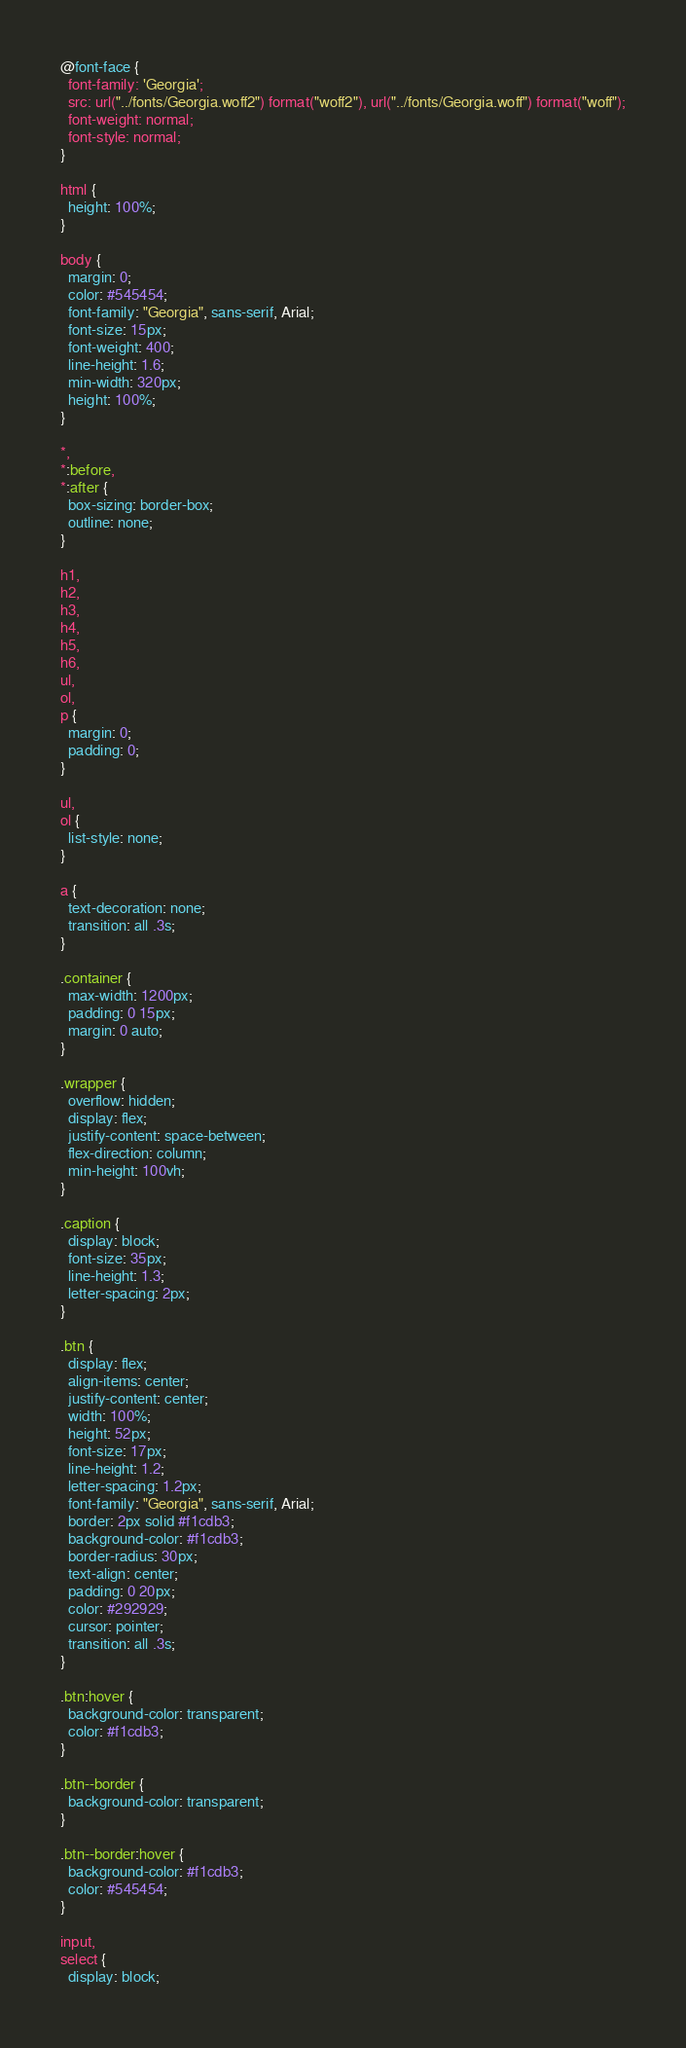<code> <loc_0><loc_0><loc_500><loc_500><_CSS_>@font-face {
  font-family: 'Georgia';
  src: url("../fonts/Georgia.woff2") format("woff2"), url("../fonts/Georgia.woff") format("woff");
  font-weight: normal;
  font-style: normal;
}

html {
  height: 100%;
}

body {
  margin: 0;
  color: #545454;
  font-family: "Georgia", sans-serif, Arial;
  font-size: 15px;
  font-weight: 400;
  line-height: 1.6;
  min-width: 320px;
  height: 100%;
}

*,
*:before,
*:after {
  box-sizing: border-box;
  outline: none;
}

h1,
h2,
h3,
h4,
h5,
h6,
ul,
ol,
p {
  margin: 0;
  padding: 0;
}

ul,
ol {
  list-style: none;
}

a {
  text-decoration: none;
  transition: all .3s;
}

.container {
  max-width: 1200px;
  padding: 0 15px;
  margin: 0 auto;
}

.wrapper {
  overflow: hidden;
  display: flex;
  justify-content: space-between;
  flex-direction: column;
  min-height: 100vh;
}

.caption {
  display: block;
  font-size: 35px;
  line-height: 1.3;
  letter-spacing: 2px;
}

.btn {
  display: flex;
  align-items: center;
  justify-content: center;
  width: 100%;
  height: 52px;
  font-size: 17px;
  line-height: 1.2;
  letter-spacing: 1.2px;
  font-family: "Georgia", sans-serif, Arial;
  border: 2px solid #f1cdb3;
  background-color: #f1cdb3;
  border-radius: 30px;
  text-align: center;
  padding: 0 20px;
  color: #292929;
  cursor: pointer;
  transition: all .3s;
}

.btn:hover {
  background-color: transparent;
  color: #f1cdb3;
}

.btn--border {
  background-color: transparent;
}

.btn--border:hover {
  background-color: #f1cdb3;
  color: #545454;
}

input,
select {
  display: block;</code> 